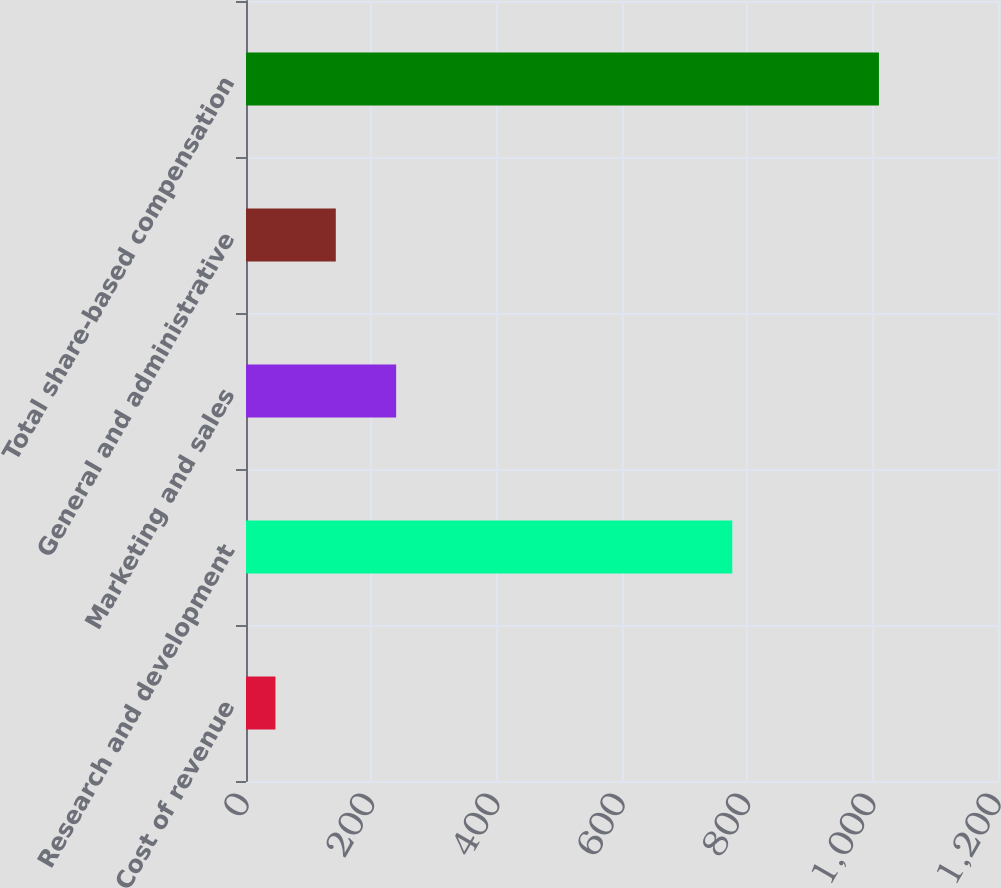<chart> <loc_0><loc_0><loc_500><loc_500><bar_chart><fcel>Cost of revenue<fcel>Research and development<fcel>Marketing and sales<fcel>General and administrative<fcel>Total share-based compensation<nl><fcel>47<fcel>776<fcel>239.6<fcel>143.3<fcel>1010<nl></chart> 